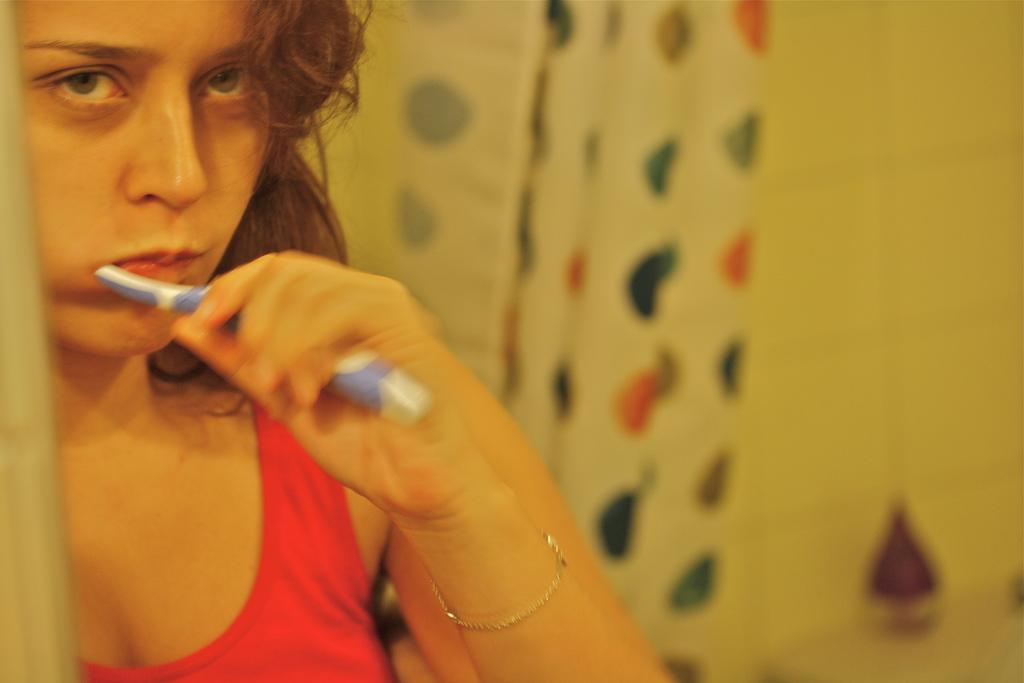How would you summarize this image in a sentence or two? In this picture we can see a woman in the red tank top and holding a toothbrush. Behind the woman there is a blurred background. 